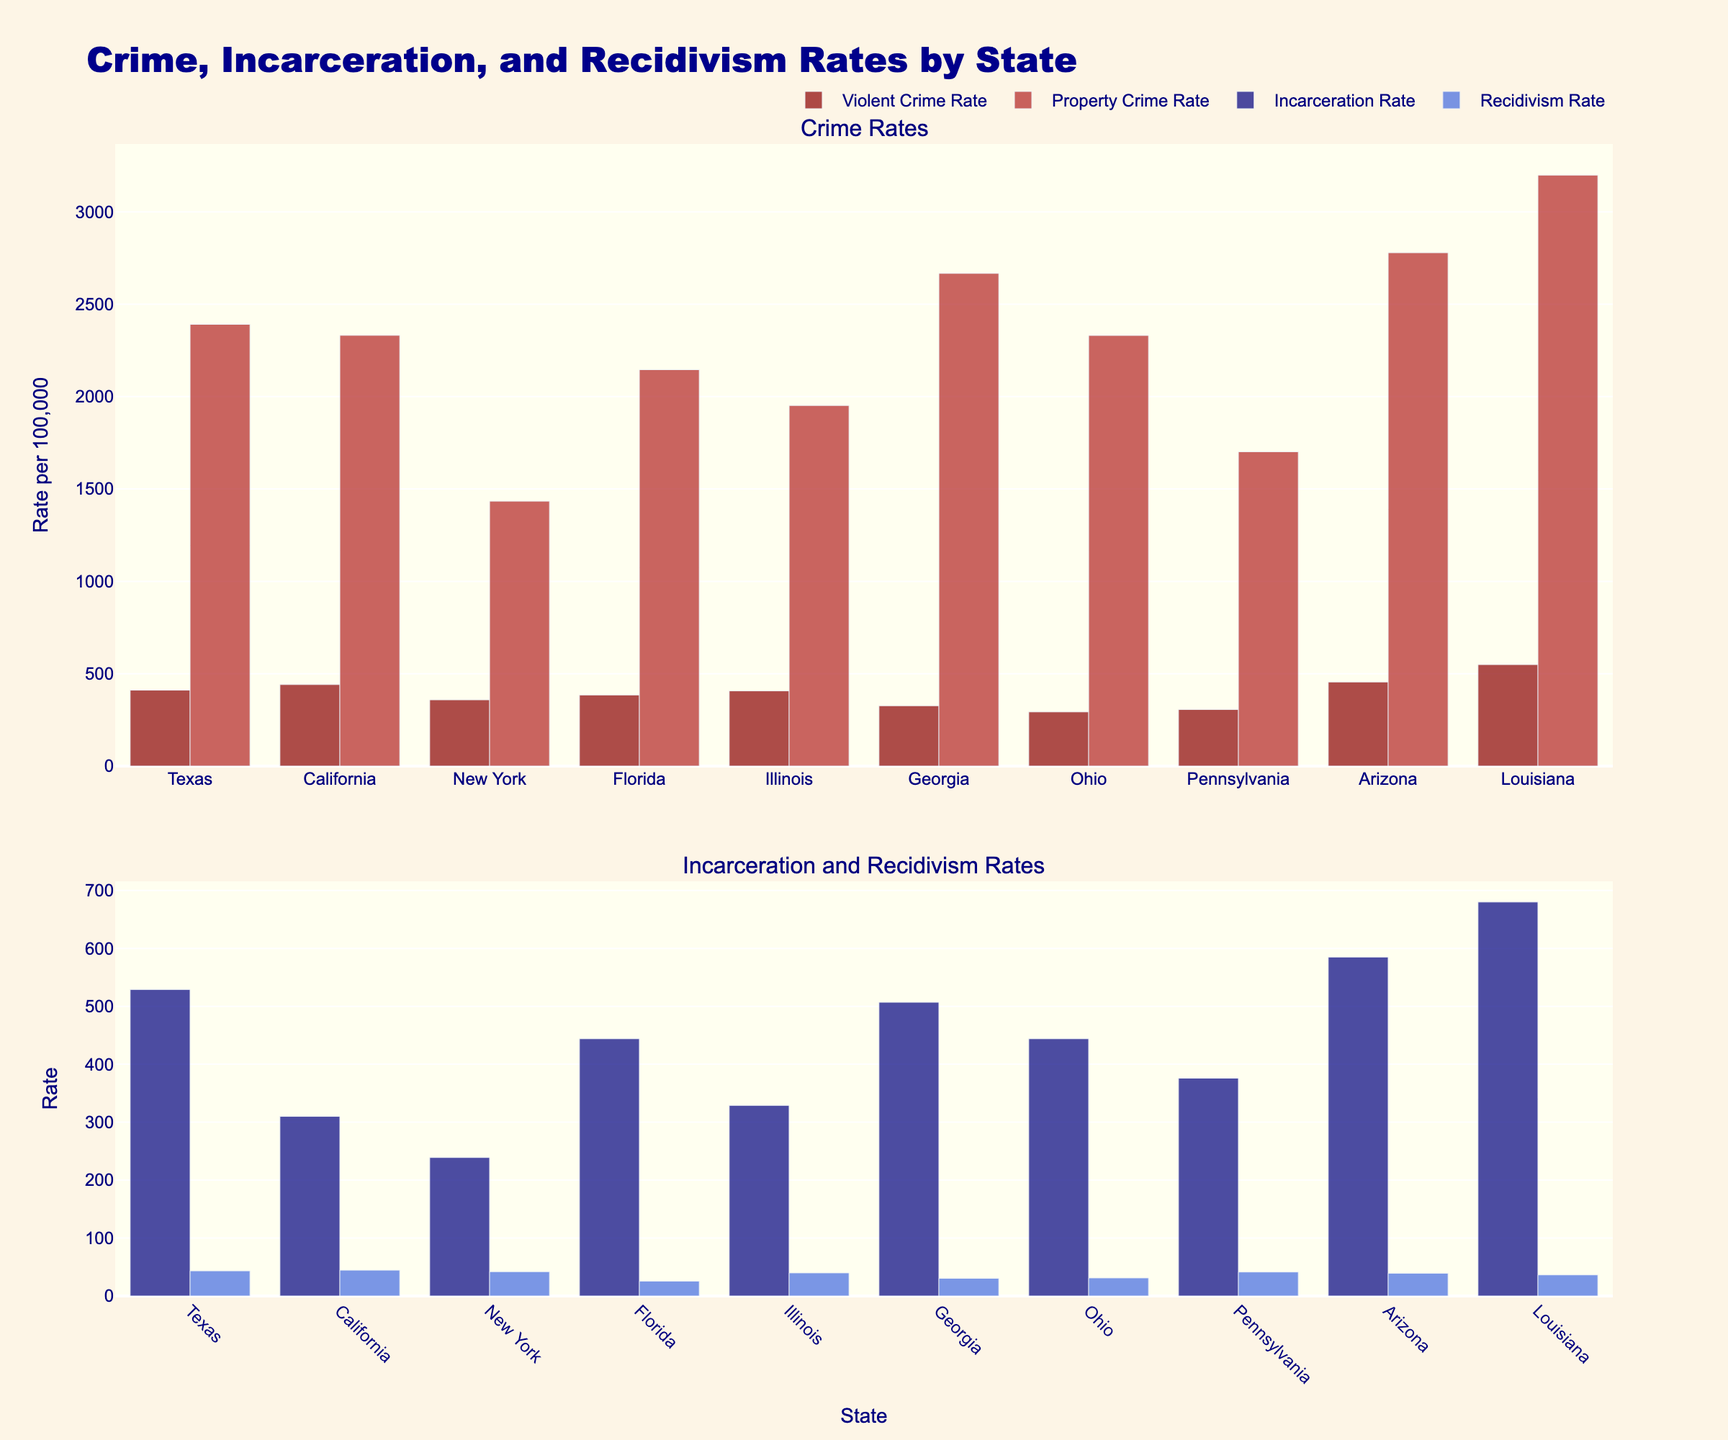Which state has the highest violent crime rate? By examining the bar chart, the state with the tallest dark red bar in the "Violent Crime Rate" category has the highest violent crime rate. Louisiana's bar is the tallest.
Answer: Louisiana Which state has the lowest property crime rate? By scanning the firebrick bars in the property crime category, New York's bar is the shortest, indicating the lowest property crime rate.
Answer: New York What is the difference in incarceration rates between Louisiana and California? From the chart, the bar in the "Incarceration Rate" category for Louisiana is higher than California's. Louisiana's incarceration rate is 680, while California's is 310. The difference is 680 - 310.
Answer: 370 Which state has a greater recidivism rate, Ohio or Pennsylvania? By comparing the royalblue bars in the recidivism category, Pennsylvania's bar is taller than Ohio's. Pennsylvania's recidivism rate is higher.
Answer: Pennsylvania What is the sum of violent crime rates for Texas, Ohio, and Arizona? According to the chart, Texas has a rate of 410.9, Ohio 293.2, and Arizona 455.3. Adding these gives 410.9 + 293.2 + 455.3.
Answer: 1159.4 Identify the state with the highest total crime rate (sum of violent and property crime rates). Combine the violent and property crime rates for each state and identify the highest. Louisiana: 549.3 + 3198.5 = 3747.8. The other states sum to lesser values.
Answer: Louisiana How does Georgia's property crime rate compare to Texas'? Referring to the firebrick bars indicates Georgia has a higher property crime rate (2666.5) compared to Texas (2390.7).
Answer: Georgia Which state has the shortest bar in the "Incarceration Rate" category? Visually assessing the bars in the "Incarceration Rate" section, New York has the shortest bar.
Answer: New York What is the average recidivism rate across all states? For each state, note its recidivism rate, sum them (43.4 + 44.6 + 42.0 + 25.7 + 39.9 + 30.5 + 31.2 + 41.4 + 39.3 + 36.4) = 374.4, then divide by the number of states (10).
Answer: 37.44 How much higher is Louisiana's violent crime rate compared to New York's? Subtract New York’s violent crime rate (358.6) from Louisiana’s (549.3). The difference is 549.3 - 358.6.
Answer: 190.7 